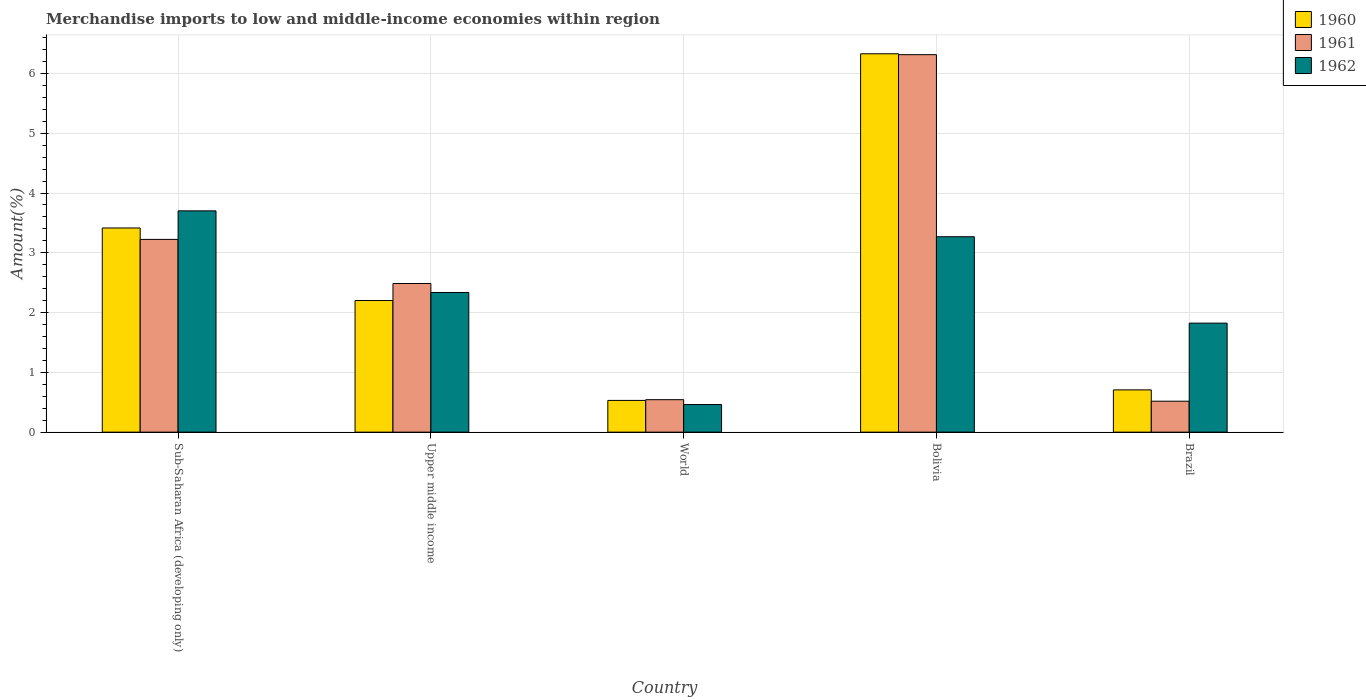How many different coloured bars are there?
Keep it short and to the point. 3. Are the number of bars per tick equal to the number of legend labels?
Provide a short and direct response. Yes. How many bars are there on the 3rd tick from the right?
Provide a short and direct response. 3. What is the percentage of amount earned from merchandise imports in 1960 in Bolivia?
Your answer should be very brief. 6.33. Across all countries, what is the maximum percentage of amount earned from merchandise imports in 1961?
Make the answer very short. 6.31. Across all countries, what is the minimum percentage of amount earned from merchandise imports in 1960?
Your answer should be compact. 0.53. In which country was the percentage of amount earned from merchandise imports in 1960 maximum?
Provide a succinct answer. Bolivia. What is the total percentage of amount earned from merchandise imports in 1960 in the graph?
Ensure brevity in your answer.  13.18. What is the difference between the percentage of amount earned from merchandise imports in 1962 in Bolivia and that in World?
Provide a short and direct response. 2.81. What is the difference between the percentage of amount earned from merchandise imports in 1962 in Sub-Saharan Africa (developing only) and the percentage of amount earned from merchandise imports in 1961 in Brazil?
Keep it short and to the point. 3.18. What is the average percentage of amount earned from merchandise imports in 1962 per country?
Offer a very short reply. 2.32. What is the difference between the percentage of amount earned from merchandise imports of/in 1960 and percentage of amount earned from merchandise imports of/in 1962 in Sub-Saharan Africa (developing only)?
Provide a short and direct response. -0.29. In how many countries, is the percentage of amount earned from merchandise imports in 1960 greater than 4.6 %?
Your answer should be compact. 1. What is the ratio of the percentage of amount earned from merchandise imports in 1960 in Upper middle income to that in World?
Your answer should be compact. 4.15. Is the percentage of amount earned from merchandise imports in 1962 in Sub-Saharan Africa (developing only) less than that in World?
Make the answer very short. No. What is the difference between the highest and the second highest percentage of amount earned from merchandise imports in 1960?
Offer a terse response. -1.21. What is the difference between the highest and the lowest percentage of amount earned from merchandise imports in 1961?
Your answer should be very brief. 5.8. In how many countries, is the percentage of amount earned from merchandise imports in 1960 greater than the average percentage of amount earned from merchandise imports in 1960 taken over all countries?
Provide a succinct answer. 2. How many bars are there?
Ensure brevity in your answer.  15. Are all the bars in the graph horizontal?
Offer a very short reply. No. How many countries are there in the graph?
Your answer should be compact. 5. Are the values on the major ticks of Y-axis written in scientific E-notation?
Provide a short and direct response. No. Does the graph contain any zero values?
Ensure brevity in your answer.  No. Does the graph contain grids?
Keep it short and to the point. Yes. How many legend labels are there?
Offer a very short reply. 3. How are the legend labels stacked?
Provide a short and direct response. Vertical. What is the title of the graph?
Your response must be concise. Merchandise imports to low and middle-income economies within region. What is the label or title of the X-axis?
Your response must be concise. Country. What is the label or title of the Y-axis?
Ensure brevity in your answer.  Amount(%). What is the Amount(%) of 1960 in Sub-Saharan Africa (developing only)?
Provide a short and direct response. 3.42. What is the Amount(%) in 1961 in Sub-Saharan Africa (developing only)?
Give a very brief answer. 3.22. What is the Amount(%) in 1962 in Sub-Saharan Africa (developing only)?
Your response must be concise. 3.7. What is the Amount(%) of 1960 in Upper middle income?
Your answer should be compact. 2.2. What is the Amount(%) in 1961 in Upper middle income?
Give a very brief answer. 2.49. What is the Amount(%) of 1962 in Upper middle income?
Your answer should be very brief. 2.34. What is the Amount(%) in 1960 in World?
Give a very brief answer. 0.53. What is the Amount(%) in 1961 in World?
Give a very brief answer. 0.54. What is the Amount(%) in 1962 in World?
Offer a terse response. 0.46. What is the Amount(%) of 1960 in Bolivia?
Your response must be concise. 6.33. What is the Amount(%) of 1961 in Bolivia?
Offer a terse response. 6.31. What is the Amount(%) of 1962 in Bolivia?
Your response must be concise. 3.27. What is the Amount(%) in 1960 in Brazil?
Offer a very short reply. 0.71. What is the Amount(%) in 1961 in Brazil?
Offer a very short reply. 0.52. What is the Amount(%) of 1962 in Brazil?
Provide a succinct answer. 1.82. Across all countries, what is the maximum Amount(%) in 1960?
Your answer should be very brief. 6.33. Across all countries, what is the maximum Amount(%) of 1961?
Give a very brief answer. 6.31. Across all countries, what is the maximum Amount(%) of 1962?
Make the answer very short. 3.7. Across all countries, what is the minimum Amount(%) in 1960?
Ensure brevity in your answer.  0.53. Across all countries, what is the minimum Amount(%) of 1961?
Provide a succinct answer. 0.52. Across all countries, what is the minimum Amount(%) of 1962?
Offer a very short reply. 0.46. What is the total Amount(%) in 1960 in the graph?
Provide a succinct answer. 13.18. What is the total Amount(%) of 1961 in the graph?
Keep it short and to the point. 13.09. What is the total Amount(%) in 1962 in the graph?
Give a very brief answer. 11.59. What is the difference between the Amount(%) of 1960 in Sub-Saharan Africa (developing only) and that in Upper middle income?
Your response must be concise. 1.21. What is the difference between the Amount(%) of 1961 in Sub-Saharan Africa (developing only) and that in Upper middle income?
Your answer should be very brief. 0.74. What is the difference between the Amount(%) of 1962 in Sub-Saharan Africa (developing only) and that in Upper middle income?
Make the answer very short. 1.37. What is the difference between the Amount(%) in 1960 in Sub-Saharan Africa (developing only) and that in World?
Give a very brief answer. 2.88. What is the difference between the Amount(%) of 1961 in Sub-Saharan Africa (developing only) and that in World?
Your answer should be very brief. 2.68. What is the difference between the Amount(%) of 1962 in Sub-Saharan Africa (developing only) and that in World?
Your answer should be very brief. 3.24. What is the difference between the Amount(%) of 1960 in Sub-Saharan Africa (developing only) and that in Bolivia?
Your answer should be compact. -2.91. What is the difference between the Amount(%) of 1961 in Sub-Saharan Africa (developing only) and that in Bolivia?
Offer a terse response. -3.09. What is the difference between the Amount(%) of 1962 in Sub-Saharan Africa (developing only) and that in Bolivia?
Give a very brief answer. 0.43. What is the difference between the Amount(%) in 1960 in Sub-Saharan Africa (developing only) and that in Brazil?
Your answer should be compact. 2.71. What is the difference between the Amount(%) in 1961 in Sub-Saharan Africa (developing only) and that in Brazil?
Keep it short and to the point. 2.71. What is the difference between the Amount(%) of 1962 in Sub-Saharan Africa (developing only) and that in Brazil?
Give a very brief answer. 1.88. What is the difference between the Amount(%) of 1960 in Upper middle income and that in World?
Your answer should be compact. 1.67. What is the difference between the Amount(%) in 1961 in Upper middle income and that in World?
Provide a succinct answer. 1.94. What is the difference between the Amount(%) of 1962 in Upper middle income and that in World?
Ensure brevity in your answer.  1.87. What is the difference between the Amount(%) in 1960 in Upper middle income and that in Bolivia?
Your answer should be compact. -4.13. What is the difference between the Amount(%) of 1961 in Upper middle income and that in Bolivia?
Your answer should be compact. -3.83. What is the difference between the Amount(%) of 1962 in Upper middle income and that in Bolivia?
Give a very brief answer. -0.93. What is the difference between the Amount(%) of 1960 in Upper middle income and that in Brazil?
Your response must be concise. 1.49. What is the difference between the Amount(%) in 1961 in Upper middle income and that in Brazil?
Your answer should be compact. 1.97. What is the difference between the Amount(%) of 1962 in Upper middle income and that in Brazil?
Offer a very short reply. 0.51. What is the difference between the Amount(%) in 1960 in World and that in Bolivia?
Your answer should be very brief. -5.8. What is the difference between the Amount(%) in 1961 in World and that in Bolivia?
Your response must be concise. -5.77. What is the difference between the Amount(%) in 1962 in World and that in Bolivia?
Give a very brief answer. -2.81. What is the difference between the Amount(%) in 1960 in World and that in Brazil?
Ensure brevity in your answer.  -0.18. What is the difference between the Amount(%) of 1961 in World and that in Brazil?
Provide a succinct answer. 0.03. What is the difference between the Amount(%) in 1962 in World and that in Brazil?
Your answer should be compact. -1.36. What is the difference between the Amount(%) of 1960 in Bolivia and that in Brazil?
Keep it short and to the point. 5.62. What is the difference between the Amount(%) in 1961 in Bolivia and that in Brazil?
Provide a succinct answer. 5.8. What is the difference between the Amount(%) in 1962 in Bolivia and that in Brazil?
Offer a very short reply. 1.45. What is the difference between the Amount(%) of 1960 in Sub-Saharan Africa (developing only) and the Amount(%) of 1961 in Upper middle income?
Provide a short and direct response. 0.93. What is the difference between the Amount(%) in 1960 in Sub-Saharan Africa (developing only) and the Amount(%) in 1962 in Upper middle income?
Your answer should be very brief. 1.08. What is the difference between the Amount(%) of 1961 in Sub-Saharan Africa (developing only) and the Amount(%) of 1962 in Upper middle income?
Your answer should be very brief. 0.89. What is the difference between the Amount(%) of 1960 in Sub-Saharan Africa (developing only) and the Amount(%) of 1961 in World?
Your answer should be very brief. 2.87. What is the difference between the Amount(%) in 1960 in Sub-Saharan Africa (developing only) and the Amount(%) in 1962 in World?
Keep it short and to the point. 2.95. What is the difference between the Amount(%) in 1961 in Sub-Saharan Africa (developing only) and the Amount(%) in 1962 in World?
Keep it short and to the point. 2.76. What is the difference between the Amount(%) in 1960 in Sub-Saharan Africa (developing only) and the Amount(%) in 1961 in Bolivia?
Provide a succinct answer. -2.9. What is the difference between the Amount(%) of 1960 in Sub-Saharan Africa (developing only) and the Amount(%) of 1962 in Bolivia?
Provide a short and direct response. 0.15. What is the difference between the Amount(%) in 1961 in Sub-Saharan Africa (developing only) and the Amount(%) in 1962 in Bolivia?
Your answer should be compact. -0.04. What is the difference between the Amount(%) in 1960 in Sub-Saharan Africa (developing only) and the Amount(%) in 1961 in Brazil?
Give a very brief answer. 2.9. What is the difference between the Amount(%) in 1960 in Sub-Saharan Africa (developing only) and the Amount(%) in 1962 in Brazil?
Make the answer very short. 1.59. What is the difference between the Amount(%) in 1961 in Sub-Saharan Africa (developing only) and the Amount(%) in 1962 in Brazil?
Offer a very short reply. 1.4. What is the difference between the Amount(%) in 1960 in Upper middle income and the Amount(%) in 1961 in World?
Ensure brevity in your answer.  1.66. What is the difference between the Amount(%) of 1960 in Upper middle income and the Amount(%) of 1962 in World?
Offer a very short reply. 1.74. What is the difference between the Amount(%) of 1961 in Upper middle income and the Amount(%) of 1962 in World?
Ensure brevity in your answer.  2.02. What is the difference between the Amount(%) in 1960 in Upper middle income and the Amount(%) in 1961 in Bolivia?
Offer a terse response. -4.11. What is the difference between the Amount(%) of 1960 in Upper middle income and the Amount(%) of 1962 in Bolivia?
Your answer should be compact. -1.07. What is the difference between the Amount(%) of 1961 in Upper middle income and the Amount(%) of 1962 in Bolivia?
Your response must be concise. -0.78. What is the difference between the Amount(%) in 1960 in Upper middle income and the Amount(%) in 1961 in Brazil?
Your response must be concise. 1.68. What is the difference between the Amount(%) in 1960 in Upper middle income and the Amount(%) in 1962 in Brazil?
Ensure brevity in your answer.  0.38. What is the difference between the Amount(%) in 1961 in Upper middle income and the Amount(%) in 1962 in Brazil?
Keep it short and to the point. 0.66. What is the difference between the Amount(%) in 1960 in World and the Amount(%) in 1961 in Bolivia?
Offer a very short reply. -5.78. What is the difference between the Amount(%) in 1960 in World and the Amount(%) in 1962 in Bolivia?
Give a very brief answer. -2.74. What is the difference between the Amount(%) in 1961 in World and the Amount(%) in 1962 in Bolivia?
Provide a succinct answer. -2.73. What is the difference between the Amount(%) of 1960 in World and the Amount(%) of 1961 in Brazil?
Offer a very short reply. 0.01. What is the difference between the Amount(%) of 1960 in World and the Amount(%) of 1962 in Brazil?
Your answer should be very brief. -1.29. What is the difference between the Amount(%) in 1961 in World and the Amount(%) in 1962 in Brazil?
Your response must be concise. -1.28. What is the difference between the Amount(%) of 1960 in Bolivia and the Amount(%) of 1961 in Brazil?
Provide a short and direct response. 5.81. What is the difference between the Amount(%) of 1960 in Bolivia and the Amount(%) of 1962 in Brazil?
Give a very brief answer. 4.51. What is the difference between the Amount(%) of 1961 in Bolivia and the Amount(%) of 1962 in Brazil?
Your answer should be very brief. 4.49. What is the average Amount(%) of 1960 per country?
Give a very brief answer. 2.64. What is the average Amount(%) of 1961 per country?
Your answer should be very brief. 2.62. What is the average Amount(%) of 1962 per country?
Provide a succinct answer. 2.32. What is the difference between the Amount(%) of 1960 and Amount(%) of 1961 in Sub-Saharan Africa (developing only)?
Provide a short and direct response. 0.19. What is the difference between the Amount(%) of 1960 and Amount(%) of 1962 in Sub-Saharan Africa (developing only)?
Your response must be concise. -0.29. What is the difference between the Amount(%) in 1961 and Amount(%) in 1962 in Sub-Saharan Africa (developing only)?
Provide a short and direct response. -0.48. What is the difference between the Amount(%) of 1960 and Amount(%) of 1961 in Upper middle income?
Provide a short and direct response. -0.28. What is the difference between the Amount(%) of 1960 and Amount(%) of 1962 in Upper middle income?
Offer a very short reply. -0.13. What is the difference between the Amount(%) in 1961 and Amount(%) in 1962 in Upper middle income?
Your response must be concise. 0.15. What is the difference between the Amount(%) of 1960 and Amount(%) of 1961 in World?
Your answer should be compact. -0.01. What is the difference between the Amount(%) of 1960 and Amount(%) of 1962 in World?
Keep it short and to the point. 0.07. What is the difference between the Amount(%) in 1961 and Amount(%) in 1962 in World?
Your answer should be very brief. 0.08. What is the difference between the Amount(%) of 1960 and Amount(%) of 1961 in Bolivia?
Give a very brief answer. 0.01. What is the difference between the Amount(%) of 1960 and Amount(%) of 1962 in Bolivia?
Your answer should be very brief. 3.06. What is the difference between the Amount(%) of 1961 and Amount(%) of 1962 in Bolivia?
Keep it short and to the point. 3.05. What is the difference between the Amount(%) of 1960 and Amount(%) of 1961 in Brazil?
Your answer should be compact. 0.19. What is the difference between the Amount(%) in 1960 and Amount(%) in 1962 in Brazil?
Keep it short and to the point. -1.12. What is the difference between the Amount(%) in 1961 and Amount(%) in 1962 in Brazil?
Offer a terse response. -1.31. What is the ratio of the Amount(%) of 1960 in Sub-Saharan Africa (developing only) to that in Upper middle income?
Make the answer very short. 1.55. What is the ratio of the Amount(%) in 1961 in Sub-Saharan Africa (developing only) to that in Upper middle income?
Your response must be concise. 1.3. What is the ratio of the Amount(%) in 1962 in Sub-Saharan Africa (developing only) to that in Upper middle income?
Provide a succinct answer. 1.58. What is the ratio of the Amount(%) in 1960 in Sub-Saharan Africa (developing only) to that in World?
Your response must be concise. 6.43. What is the ratio of the Amount(%) in 1961 in Sub-Saharan Africa (developing only) to that in World?
Offer a terse response. 5.94. What is the ratio of the Amount(%) of 1962 in Sub-Saharan Africa (developing only) to that in World?
Make the answer very short. 8.02. What is the ratio of the Amount(%) in 1960 in Sub-Saharan Africa (developing only) to that in Bolivia?
Provide a succinct answer. 0.54. What is the ratio of the Amount(%) of 1961 in Sub-Saharan Africa (developing only) to that in Bolivia?
Provide a succinct answer. 0.51. What is the ratio of the Amount(%) in 1962 in Sub-Saharan Africa (developing only) to that in Bolivia?
Offer a very short reply. 1.13. What is the ratio of the Amount(%) of 1960 in Sub-Saharan Africa (developing only) to that in Brazil?
Your answer should be very brief. 4.83. What is the ratio of the Amount(%) of 1961 in Sub-Saharan Africa (developing only) to that in Brazil?
Ensure brevity in your answer.  6.23. What is the ratio of the Amount(%) of 1962 in Sub-Saharan Africa (developing only) to that in Brazil?
Provide a short and direct response. 2.03. What is the ratio of the Amount(%) of 1960 in Upper middle income to that in World?
Provide a short and direct response. 4.15. What is the ratio of the Amount(%) in 1961 in Upper middle income to that in World?
Your answer should be compact. 4.58. What is the ratio of the Amount(%) of 1962 in Upper middle income to that in World?
Ensure brevity in your answer.  5.06. What is the ratio of the Amount(%) of 1960 in Upper middle income to that in Bolivia?
Your response must be concise. 0.35. What is the ratio of the Amount(%) in 1961 in Upper middle income to that in Bolivia?
Offer a terse response. 0.39. What is the ratio of the Amount(%) in 1962 in Upper middle income to that in Bolivia?
Your answer should be compact. 0.71. What is the ratio of the Amount(%) of 1960 in Upper middle income to that in Brazil?
Keep it short and to the point. 3.11. What is the ratio of the Amount(%) of 1961 in Upper middle income to that in Brazil?
Provide a succinct answer. 4.8. What is the ratio of the Amount(%) in 1962 in Upper middle income to that in Brazil?
Offer a very short reply. 1.28. What is the ratio of the Amount(%) in 1960 in World to that in Bolivia?
Offer a terse response. 0.08. What is the ratio of the Amount(%) of 1961 in World to that in Bolivia?
Your response must be concise. 0.09. What is the ratio of the Amount(%) of 1962 in World to that in Bolivia?
Provide a short and direct response. 0.14. What is the ratio of the Amount(%) of 1960 in World to that in Brazil?
Keep it short and to the point. 0.75. What is the ratio of the Amount(%) of 1961 in World to that in Brazil?
Provide a short and direct response. 1.05. What is the ratio of the Amount(%) in 1962 in World to that in Brazil?
Provide a succinct answer. 0.25. What is the ratio of the Amount(%) of 1960 in Bolivia to that in Brazil?
Make the answer very short. 8.95. What is the ratio of the Amount(%) in 1961 in Bolivia to that in Brazil?
Provide a short and direct response. 12.2. What is the ratio of the Amount(%) in 1962 in Bolivia to that in Brazil?
Provide a succinct answer. 1.79. What is the difference between the highest and the second highest Amount(%) of 1960?
Make the answer very short. 2.91. What is the difference between the highest and the second highest Amount(%) of 1961?
Provide a succinct answer. 3.09. What is the difference between the highest and the second highest Amount(%) of 1962?
Your answer should be compact. 0.43. What is the difference between the highest and the lowest Amount(%) of 1960?
Keep it short and to the point. 5.8. What is the difference between the highest and the lowest Amount(%) in 1961?
Provide a short and direct response. 5.8. What is the difference between the highest and the lowest Amount(%) of 1962?
Provide a succinct answer. 3.24. 